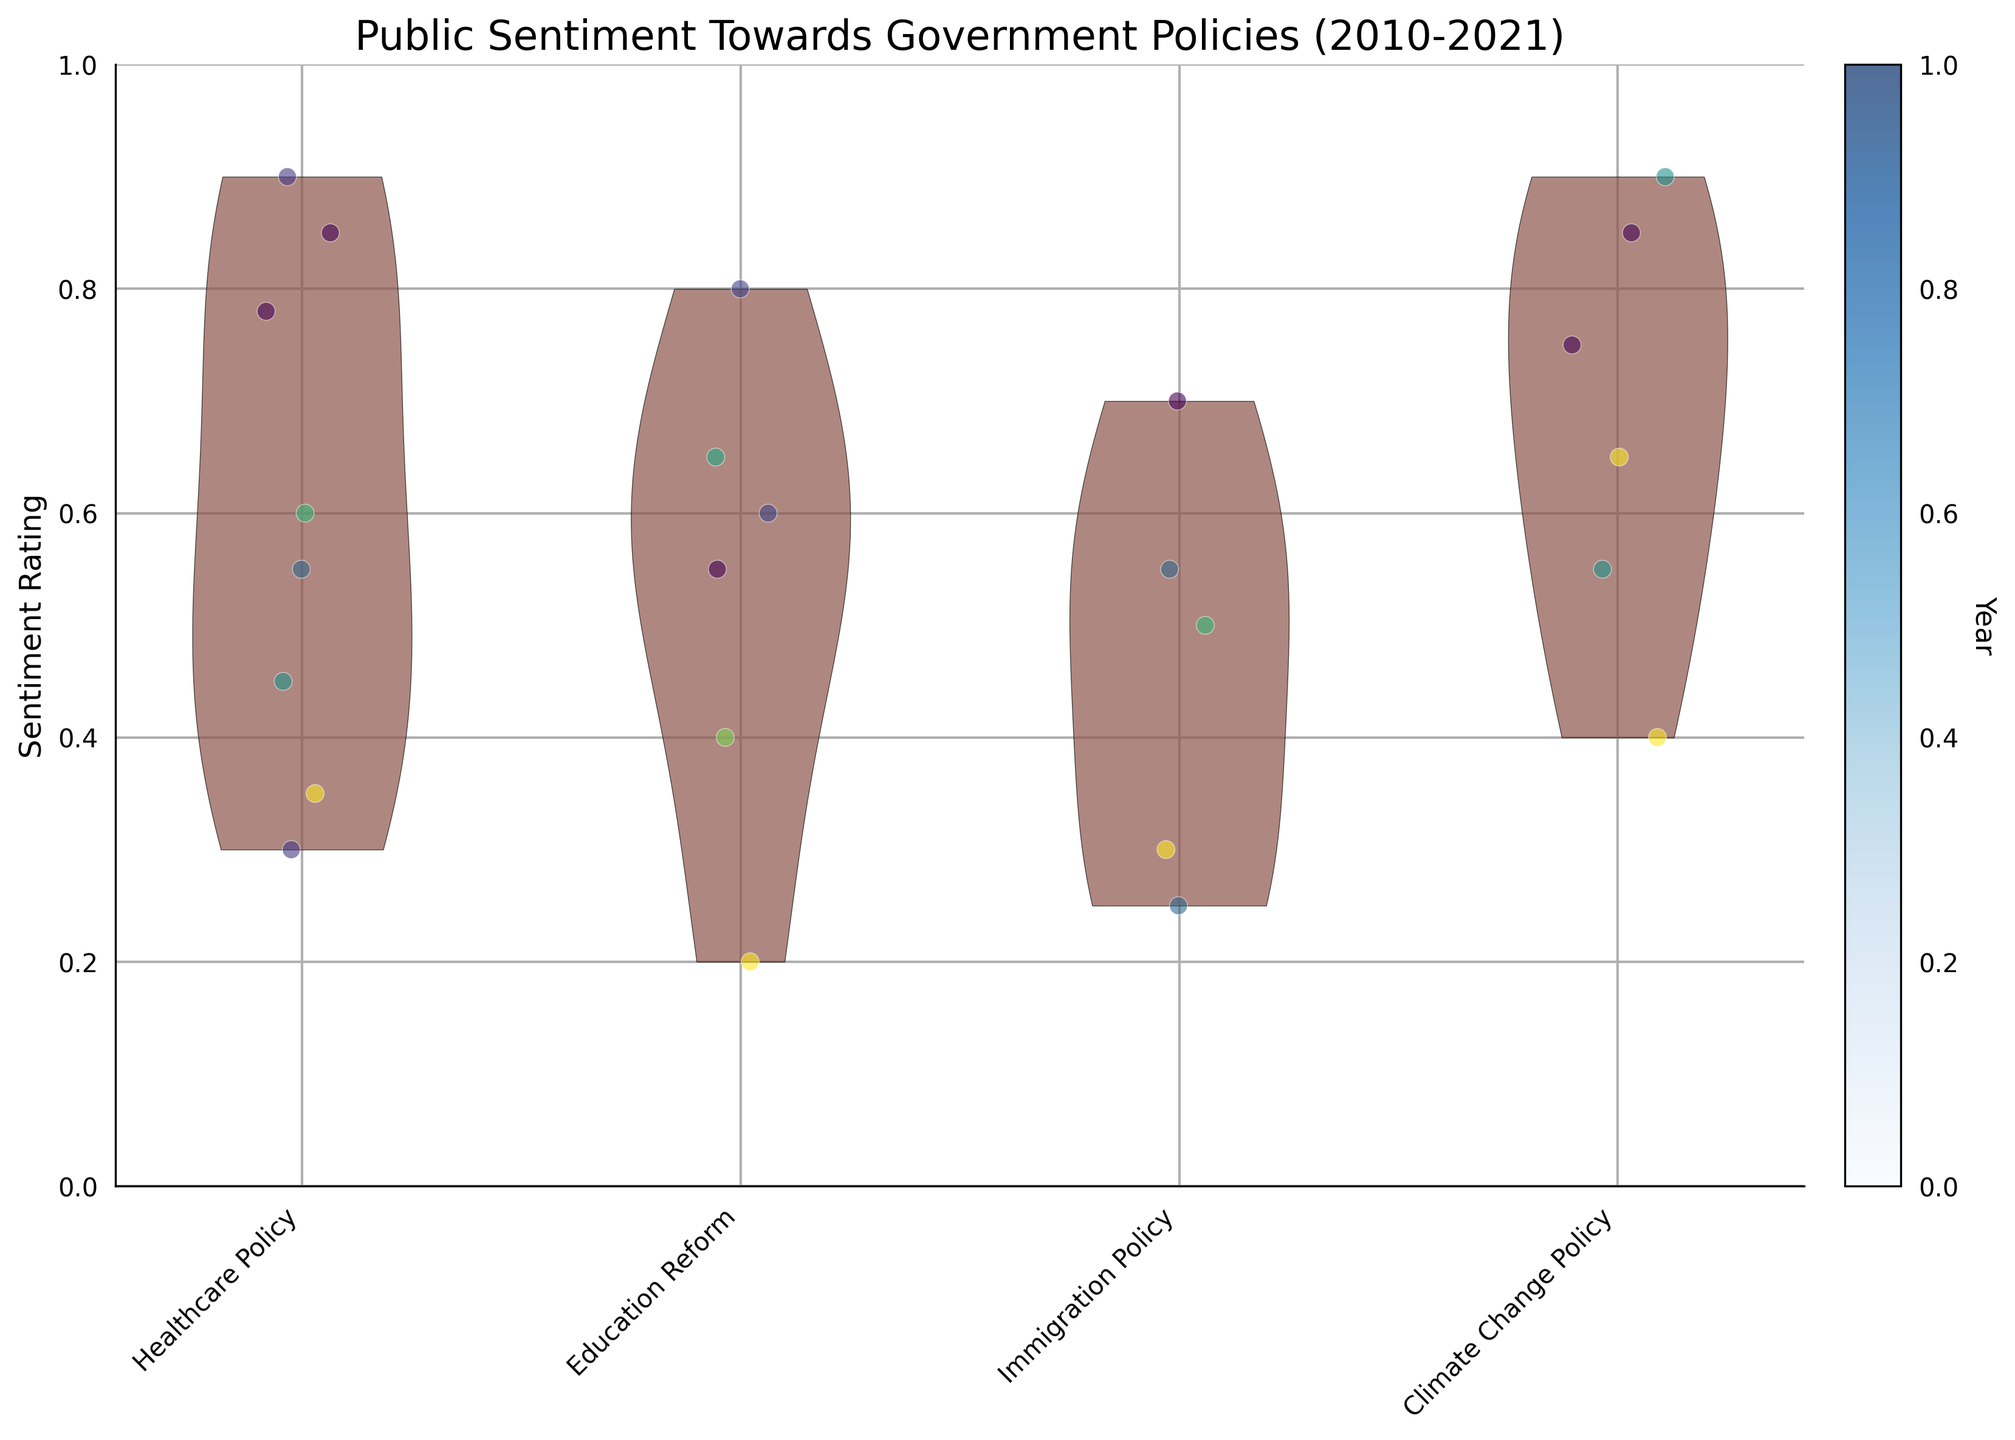What's the title of the chart? The title is located at the top of the chart and is presented to summarize the overall content of the figure. It reads "Public Sentiment Towards Government Policies (2010-2021)"
Answer: Public Sentiment Towards Government Policies (2010-2021) What is the y-axis representing? The label on the y-axis indicates what this axis measures. It reads "Sentiment Rating," which means it measures the sentiment rating of public opinions toward government policies.
Answer: Sentiment Rating Which policy has the most positive sentiment rating? By examining the scales on the y-axis and looking at the distribution of data points (where higher positions correspond to more positive sentiment), we see "Climate Change Policy" with several points clustered near the top.
Answer: Climate Change Policy How are the data points color-coded with respect to years? The color bar on the right side of the chart shows how the colors correspond to different years, with a gradient from a lighter shade to a darker shade.
Answer: By year (lighter to darker) Which policy has the highest density of negative sentiment ratings? Observing the violin plots, we look for the one with most data points concentrated at the lower end (near zero on the y-axis). "Immigration Policy" shows a significant density of points in this range.
Answer: Immigration Policy How does the sentiment rating for Healthcare Policy in Europe compare to North America? Comparing the density and range of ratings for "Healthcare Policy" between Europe and North America, Europe has a higher concentration of data points in the positive sentiment range than North America.
Answer: Europe has higher positive sentiment What policy has the widest range of sentiment ratings? Assessing the spread of each violin plot along the y-axis, "Healthcare Policy" shows data points spread from very low to high ratings, indicating a wide range of sentiment.
Answer: Healthcare Policy What is the sentiment trend for Climate Change Policy in Asia by year, based on the color code? By examining the color gradient within the points for "Climate Change Policy" in Asia and their corresponding positions, positive sentiments (higher points) appear to be more recent years.
Answer: More positive in recent years 